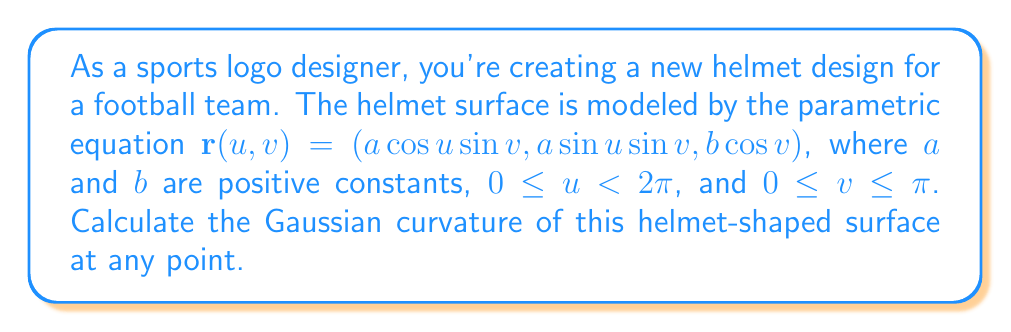Provide a solution to this math problem. To find the Gaussian curvature, we'll follow these steps:

1) First, we need to calculate the partial derivatives:
   $r_u = (-a \sin u \sin v, a \cos u \sin v, 0)$
   $r_v = (a \cos u \cos v, a \sin u \cos v, -b \sin v)$

2) Now, let's compute the coefficients of the first fundamental form:
   $E = r_u \cdot r_u = a^2 \sin^2 v$
   $F = r_u \cdot r_v = 0$
   $G = r_v \cdot r_v = a^2 \cos^2 v + b^2 \sin^2 v$

3) Next, we calculate the second partial derivatives:
   $r_{uu} = (-a \cos u \sin v, -a \sin u \sin v, 0)$
   $r_{uv} = (-a \sin u \cos v, a \cos u \cos v, 0)$
   $r_{vv} = (-a \cos u \sin v, -a \sin u \sin v, -b \cos v)$

4) We need the normal vector:
   $N = \frac{r_u \times r_v}{|r_u \times r_v|} = \frac{(b \cos u \sin v, b \sin u \sin v, a \sin v)}{\sqrt{a^2b^2 \sin^2 v}}$

5) Now we can compute the coefficients of the second fundamental form:
   $L = r_{uu} \cdot N = \frac{ab \sin^3 v}{\sqrt{a^2b^2 \sin^2 v}}$
   $M = r_{uv} \cdot N = 0$
   $N = r_{vv} \cdot N = \frac{ab \sin v}{\sqrt{a^2b^2 \sin^2 v}}$

6) The Gaussian curvature is given by:
   $K = \frac{LN - M^2}{EG - F^2}$

7) Substituting the values:
   $$K = \frac{\frac{ab \sin^3 v}{\sqrt{a^2b^2 \sin^2 v}} \cdot \frac{ab \sin v}{\sqrt{a^2b^2 \sin^2 v}} - 0^2}{a^2 \sin^2 v (a^2 \cos^2 v + b^2 \sin^2 v) - 0^2}$$

8) Simplifying:
   $$K = \frac{a^2b^2 \sin^4 v}{a^2b^2 \sin^2 v \cdot a^2 \sin^2 v (a^2 \cos^2 v + b^2 \sin^2 v)} = \frac{1}{a^2 (a^2 \cos^2 v + b^2 \sin^2 v)}$$

This is the Gaussian curvature at any point on the helmet-shaped surface.
Answer: $K = \frac{1}{a^2 (a^2 \cos^2 v + b^2 \sin^2 v)}$ 